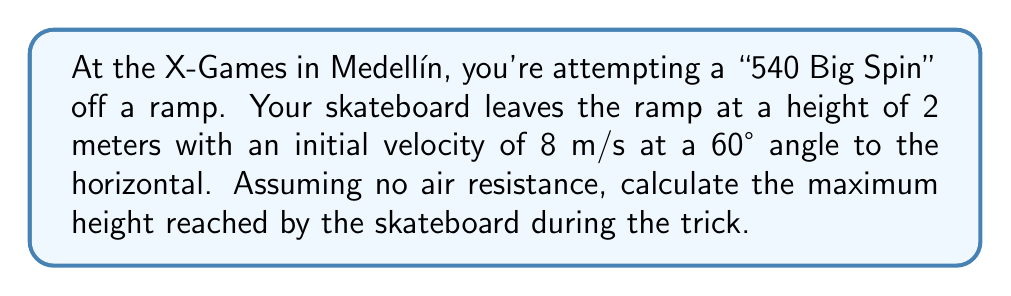Give your solution to this math problem. To solve this problem, we'll use the principles of parabolic motion. Let's break it down step-by-step:

1) In parabolic motion, the maximum height is reached when the vertical component of velocity becomes zero. We'll use the equation:

   $$v_y^2 = v_{0y}^2 - 2g(h_{max} - h_0)$$

   Where:
   $v_y$ = final vertical velocity (0 at max height)
   $v_{0y}$ = initial vertical velocity
   $g$ = acceleration due to gravity (9.8 m/s²)
   $h_{max}$ = maximum height
   $h_0$ = initial height

2) First, let's find the initial vertical velocity:
   $$v_{0y} = v_0 \sin \theta = 8 \sin 60° = 8 * \frac{\sqrt{3}}{2} = 4\sqrt{3} \text{ m/s}$$

3) Now we can substitute into our equation:

   $$0^2 = (4\sqrt{3})^2 - 2(9.8)(h_{max} - 2)$$

4) Simplify:
   $$48 = 19.6(h_{max} - 2)$$

5) Solve for $h_{max}$:
   $$h_{max} - 2 = \frac{48}{19.6} = 2.45$$
   $$h_{max} = 4.45 \text{ m}$$

6) The maximum height reached is 4.45 meters above the ground, or 2.45 meters above the starting point.
Answer: 4.45 m 